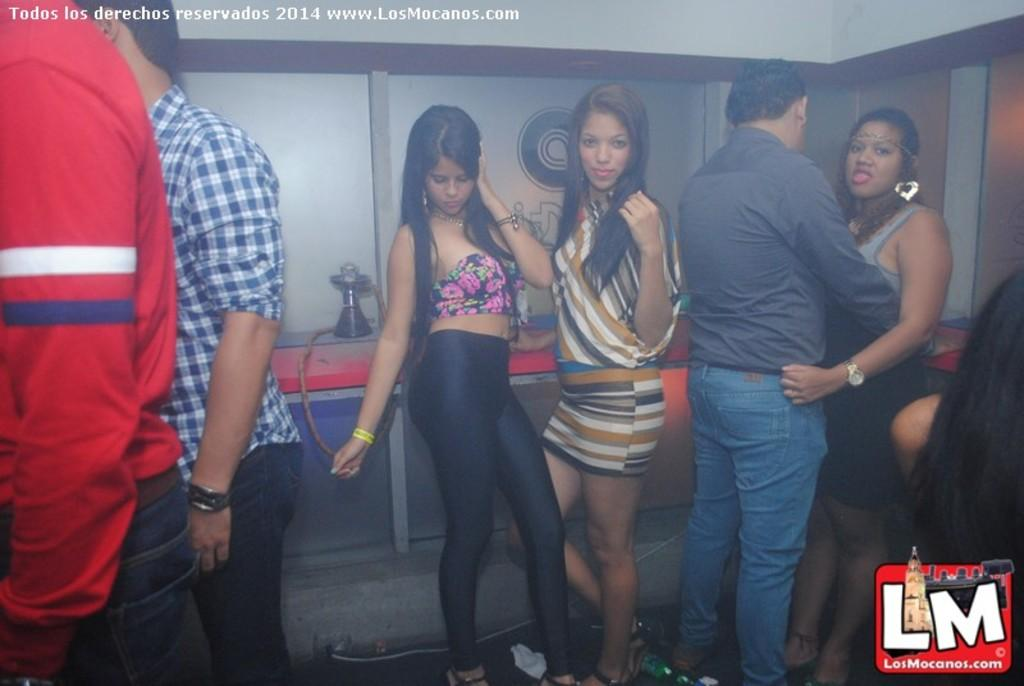What can be seen in the image? There are people standing in the image. What object is visible in the background? There is a hookah pot in the background of the image. Is there any additional information about the image? Yes, there is a watermark in the image. Can you tell me how many dolls are playing on the amusement ride in the image? There are no dolls or amusement rides present in the image; it features people standing and a hookah pot in the background. 